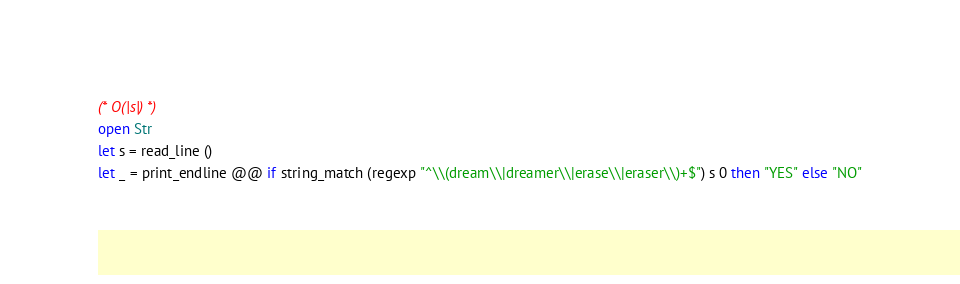Convert code to text. <code><loc_0><loc_0><loc_500><loc_500><_OCaml_>(* O(|s|) *)
open Str
let s = read_line ()
let _ = print_endline @@ if string_match (regexp "^\\(dream\\|dreamer\\|erase\\|eraser\\)+$") s 0 then "YES" else "NO"</code> 